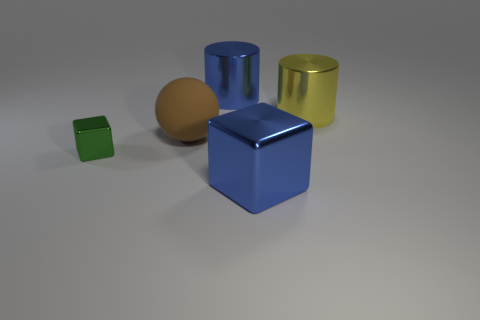Add 1 big green shiny balls. How many objects exist? 6 Subtract all cubes. How many objects are left? 3 Add 4 big metallic objects. How many big metallic objects exist? 7 Subtract 0 brown cubes. How many objects are left? 5 Subtract all big yellow shiny cylinders. Subtract all blue things. How many objects are left? 2 Add 2 brown objects. How many brown objects are left? 3 